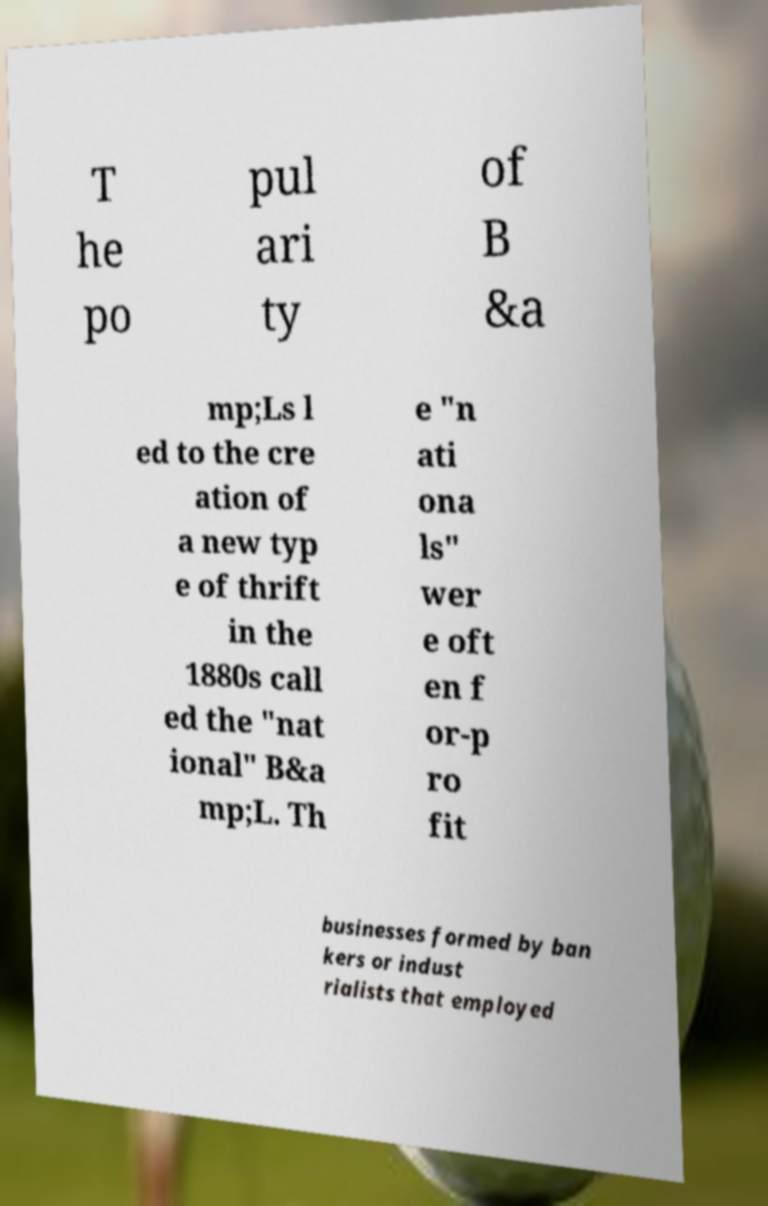Please identify and transcribe the text found in this image. T he po pul ari ty of B &a mp;Ls l ed to the cre ation of a new typ e of thrift in the 1880s call ed the "nat ional" B&a mp;L. Th e "n ati ona ls" wer e oft en f or-p ro fit businesses formed by ban kers or indust rialists that employed 